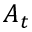<formula> <loc_0><loc_0><loc_500><loc_500>A _ { t }</formula> 